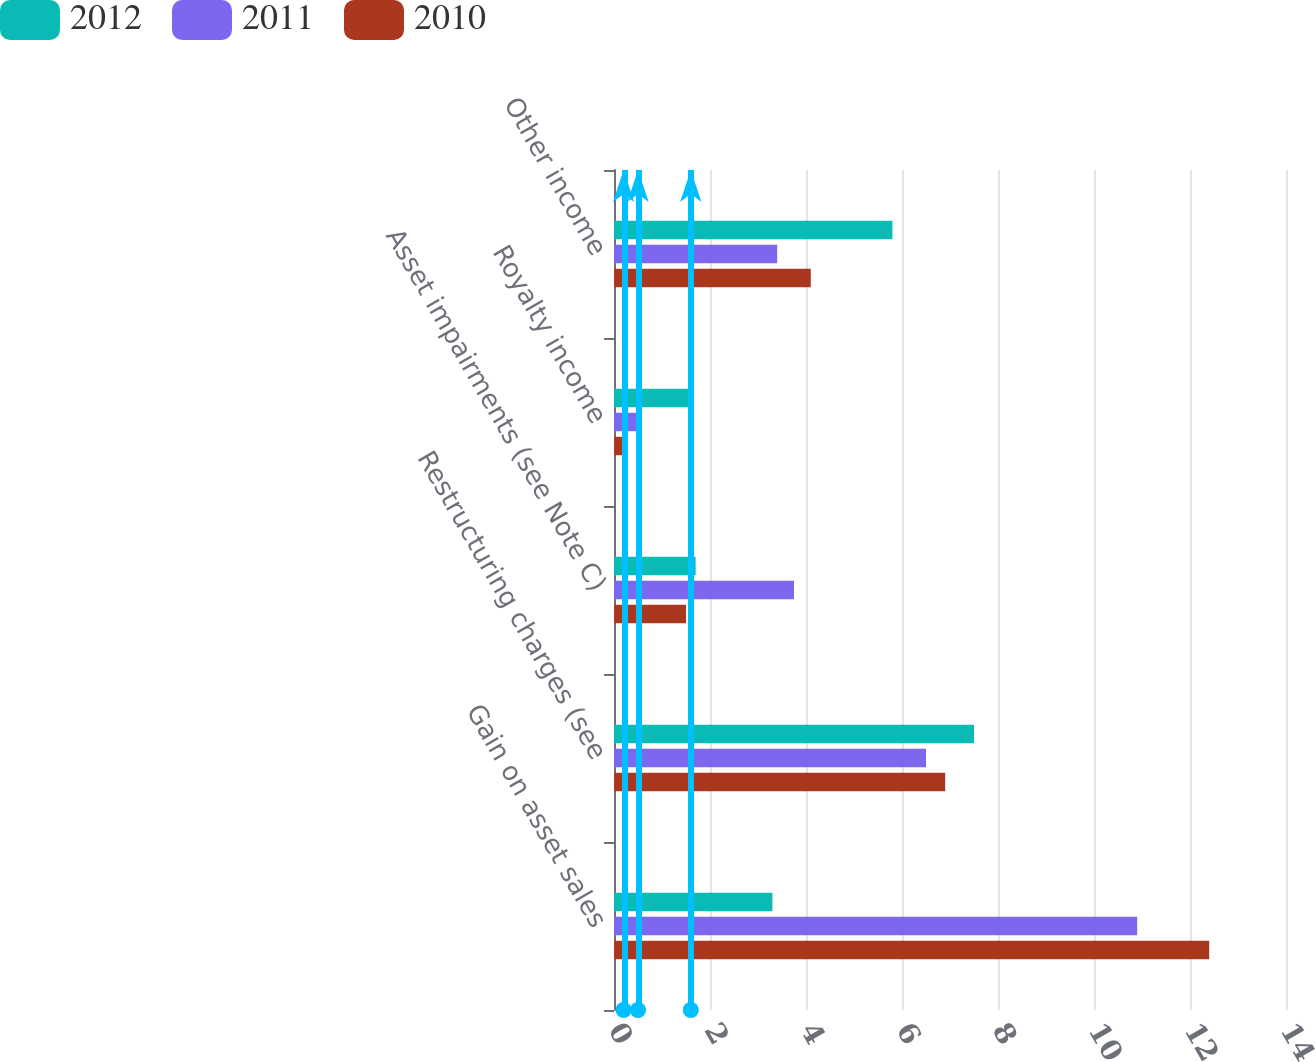Convert chart to OTSL. <chart><loc_0><loc_0><loc_500><loc_500><stacked_bar_chart><ecel><fcel>Gain on asset sales<fcel>Restructuring charges (see<fcel>Asset impairments (see Note C)<fcel>Royalty income<fcel>Other income<nl><fcel>2012<fcel>3.3<fcel>7.5<fcel>1.7<fcel>1.6<fcel>5.8<nl><fcel>2011<fcel>10.9<fcel>6.5<fcel>3.75<fcel>0.5<fcel>3.4<nl><fcel>2010<fcel>12.4<fcel>6.9<fcel>1.5<fcel>0.2<fcel>4.1<nl></chart> 